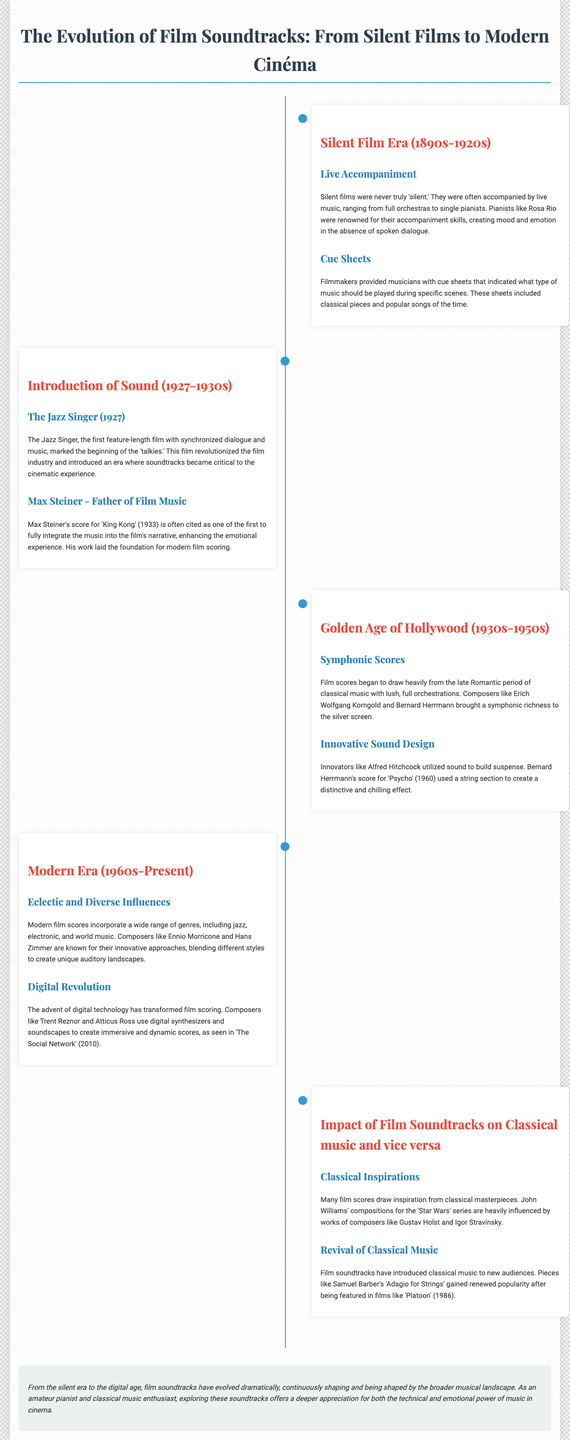What era did silent films belong to? The silent film era spans from the 1890s to the 1920s.
Answer: 1890s-1920s Who is known as the father of film music? Max Steiner is referred to as the father of film music for his contributions during the introduction of sound.
Answer: Max Steiner What film marked the beginning of the 'talkies'? 'The Jazz Singer' was the first feature-length film with synchronized dialogue and music.
Answer: The Jazz Singer Which composer is noted for the score of 'Psycho'? Bernard Herrmann composed the score for 'Psycho', known for its distinctive chilling effect.
Answer: Bernard Herrmann What genres influence modern film scores? Modern film scores incorporate jazz, electronic, and world music among others.
Answer: Jazz, electronic, and world music Which composer’s works heavily influenced John Williams' 'Star Wars' series? Gustav Holst's compositions are noted to influence John Williams' works in 'Star Wars'.
Answer: Gustav Holst What technological advancement transformed film scoring in the modern era? The advent of digital technology significantly changed how film scores are created.
Answer: Digital technology How did film soundtracks impact classical music? Film soundtracks have introduced classical music to new audiences, reviving certain pieces.
Answer: Revived classical music What notable piece was featured in the film 'Platoon'? Samuel Barber's 'Adagio for Strings' gained popularity after its feature in 'Platoon'.
Answer: Adagio for Strings 